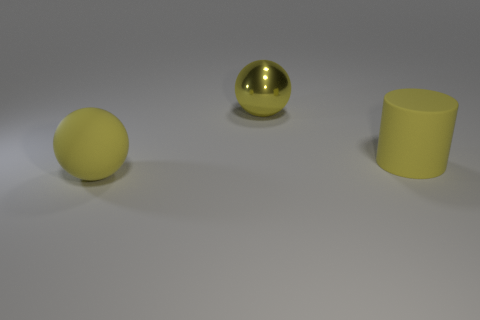Do the cylinder and the ball that is behind the big yellow rubber sphere have the same color?
Provide a short and direct response. Yes. Are there any other things that are the same color as the cylinder?
Provide a succinct answer. Yes. How many cylinders are either purple matte objects or yellow matte objects?
Your response must be concise. 1. How many things are both behind the cylinder and in front of the yellow rubber cylinder?
Offer a very short reply. 0. Is the number of large yellow objects behind the rubber cylinder the same as the number of yellow spheres left of the big matte sphere?
Your answer should be compact. No. There is a large yellow rubber thing to the right of the big matte sphere; does it have the same shape as the metal object?
Offer a terse response. No. There is a matte thing to the right of the ball that is on the right side of the large yellow ball that is in front of the big shiny sphere; what shape is it?
Keep it short and to the point. Cylinder. There is a large metal object that is the same color as the cylinder; what shape is it?
Offer a very short reply. Sphere. There is a big yellow thing that is both in front of the big shiny thing and left of the big matte cylinder; what material is it?
Make the answer very short. Rubber. Is the number of yellow metal objects less than the number of large yellow balls?
Offer a very short reply. Yes. 